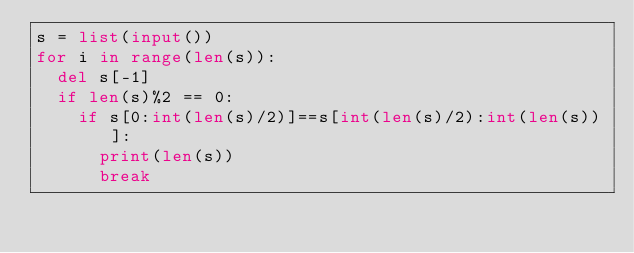<code> <loc_0><loc_0><loc_500><loc_500><_Python_>s = list(input())
for i in range(len(s)):
  del s[-1]
  if len(s)%2 == 0:
    if s[0:int(len(s)/2)]==s[int(len(s)/2):int(len(s))]:
      print(len(s))
      break</code> 